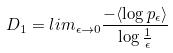<formula> <loc_0><loc_0><loc_500><loc_500>D _ { 1 } = l i m _ { \epsilon \rightarrow 0 } \frac { - \langle \log p _ { \epsilon } \rangle } { \log \frac { 1 } { \epsilon } }</formula> 